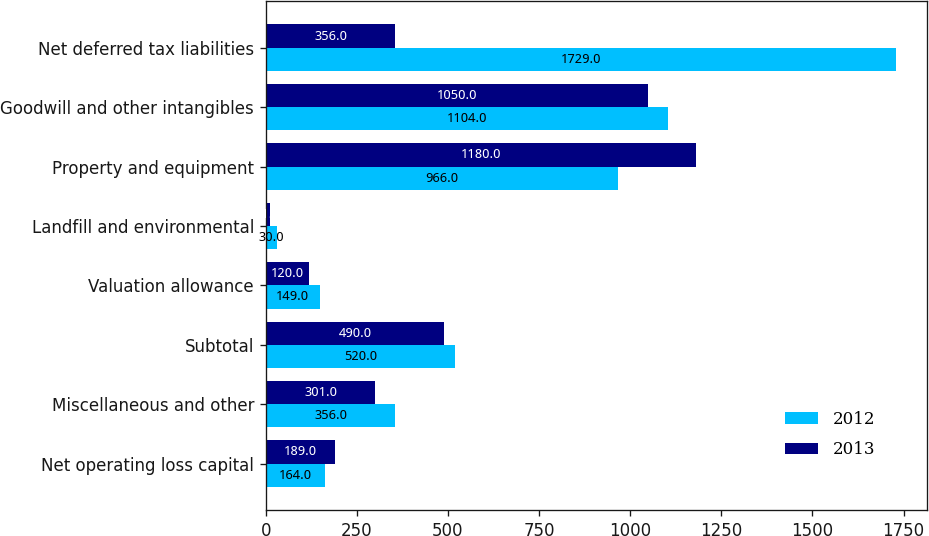<chart> <loc_0><loc_0><loc_500><loc_500><stacked_bar_chart><ecel><fcel>Net operating loss capital<fcel>Miscellaneous and other<fcel>Subtotal<fcel>Valuation allowance<fcel>Landfill and environmental<fcel>Property and equipment<fcel>Goodwill and other intangibles<fcel>Net deferred tax liabilities<nl><fcel>2012<fcel>164<fcel>356<fcel>520<fcel>149<fcel>30<fcel>966<fcel>1104<fcel>1729<nl><fcel>2013<fcel>189<fcel>301<fcel>490<fcel>120<fcel>11<fcel>1180<fcel>1050<fcel>356<nl></chart> 